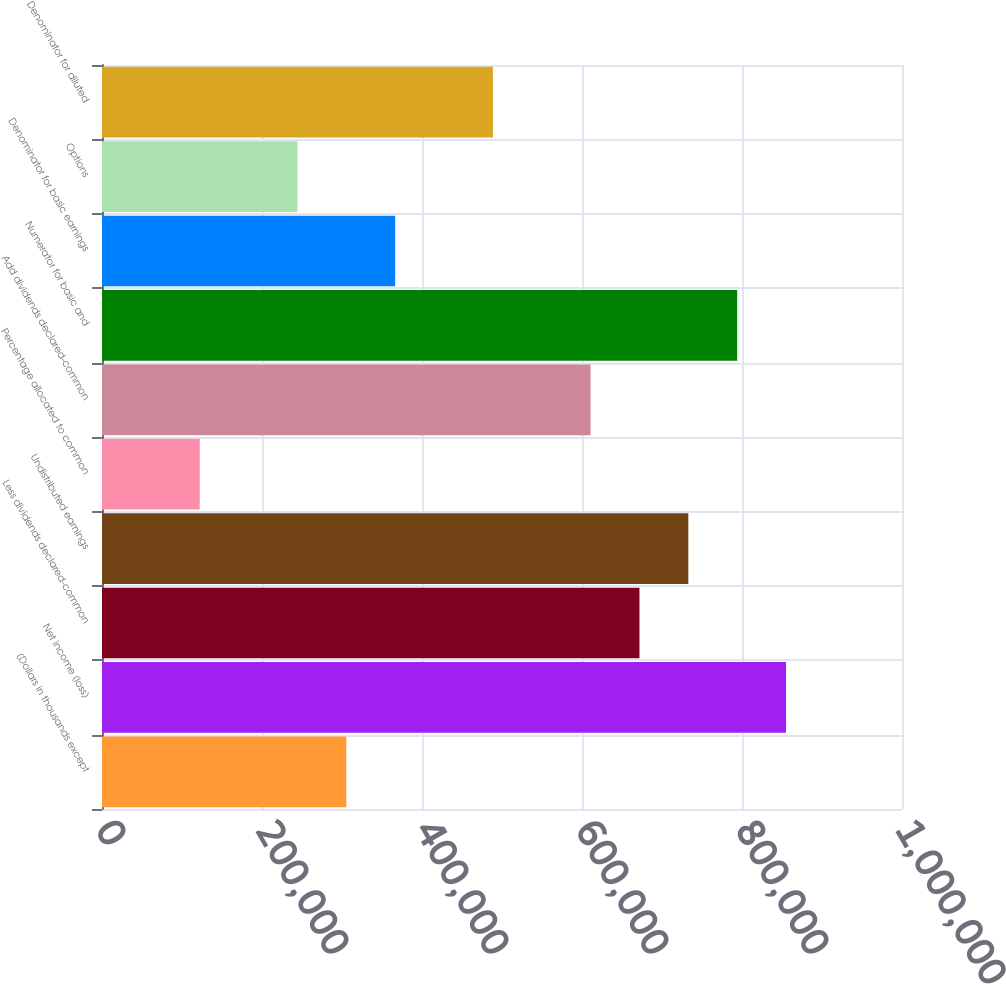Convert chart. <chart><loc_0><loc_0><loc_500><loc_500><bar_chart><fcel>(Dollars in thousands except<fcel>Net income (loss)<fcel>Less dividends declared-common<fcel>Undistributed earnings<fcel>Percentage allocated to common<fcel>Add dividends declared-common<fcel>Numerator for basic and<fcel>Denominator for basic earnings<fcel>Options<fcel>Denominator for diluted<nl><fcel>305382<fcel>855051<fcel>671828<fcel>732903<fcel>122159<fcel>610754<fcel>793977<fcel>366457<fcel>244308<fcel>488605<nl></chart> 